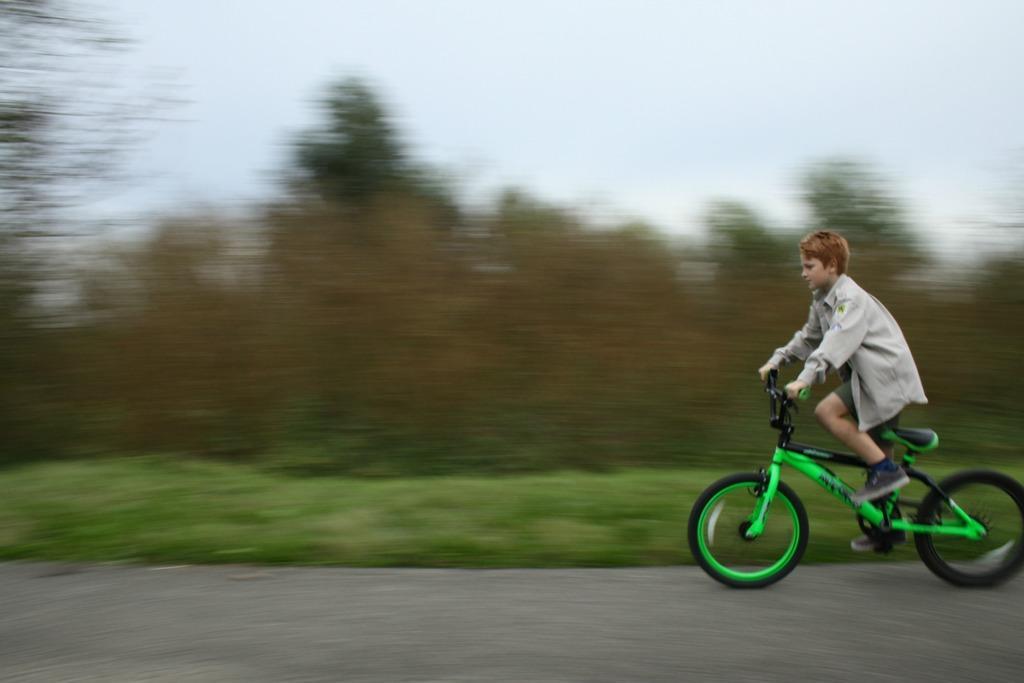Please provide a concise description of this image. In the picture we can find a boy riding a bicycle. In the background we can find some trees, plants and grass and sky. 